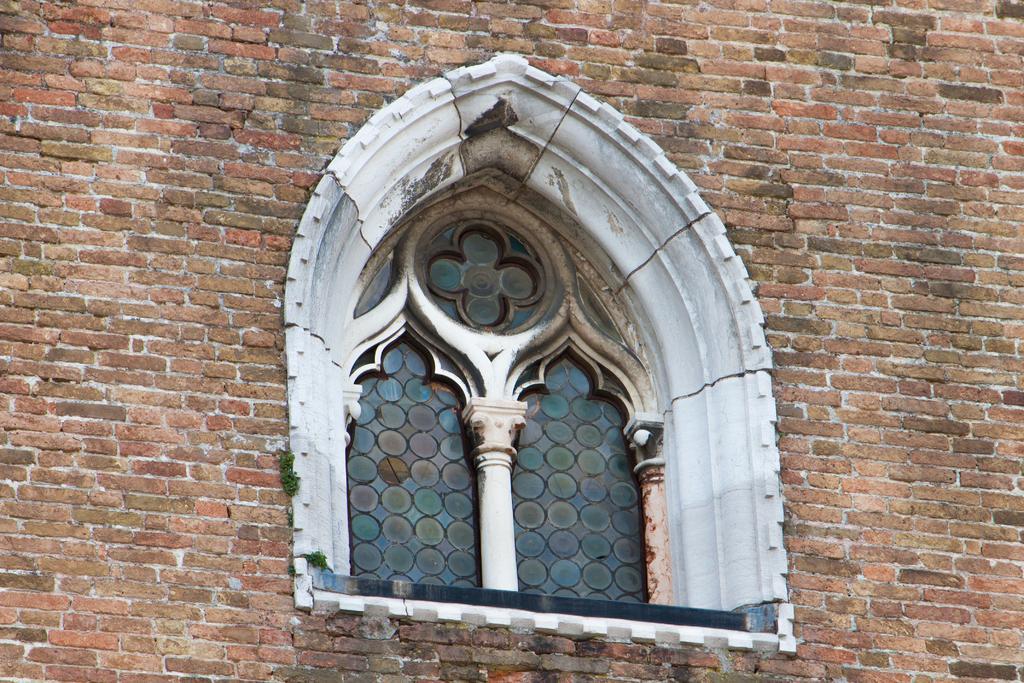Describe this image in one or two sentences. In this image we can see a wall with a window. 